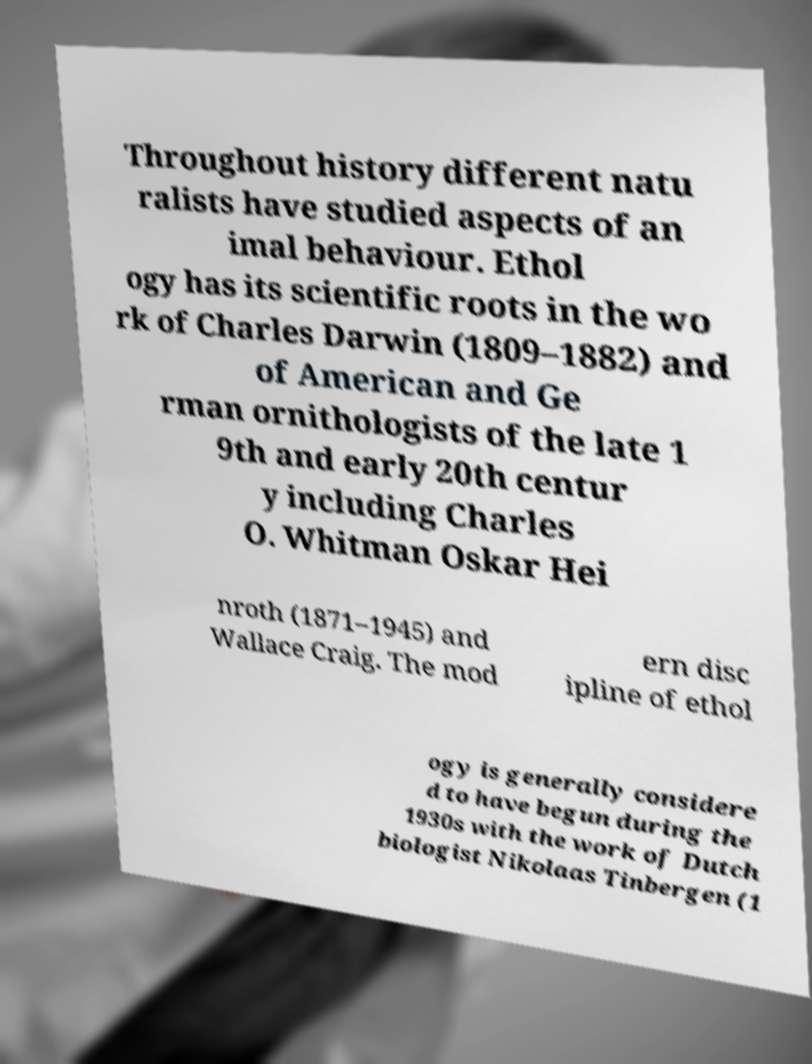Can you accurately transcribe the text from the provided image for me? Throughout history different natu ralists have studied aspects of an imal behaviour. Ethol ogy has its scientific roots in the wo rk of Charles Darwin (1809–1882) and of American and Ge rman ornithologists of the late 1 9th and early 20th centur y including Charles O. Whitman Oskar Hei nroth (1871–1945) and Wallace Craig. The mod ern disc ipline of ethol ogy is generally considere d to have begun during the 1930s with the work of Dutch biologist Nikolaas Tinbergen (1 